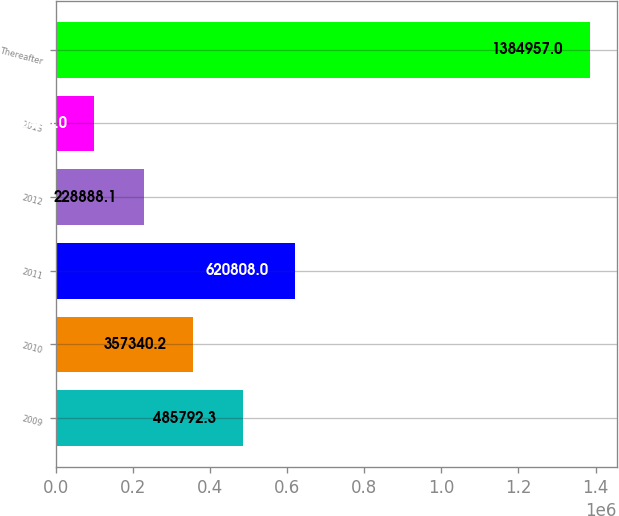Convert chart. <chart><loc_0><loc_0><loc_500><loc_500><bar_chart><fcel>2009<fcel>2010<fcel>2011<fcel>2012<fcel>2013<fcel>Thereafter<nl><fcel>485792<fcel>357340<fcel>620808<fcel>228888<fcel>100436<fcel>1.38496e+06<nl></chart> 